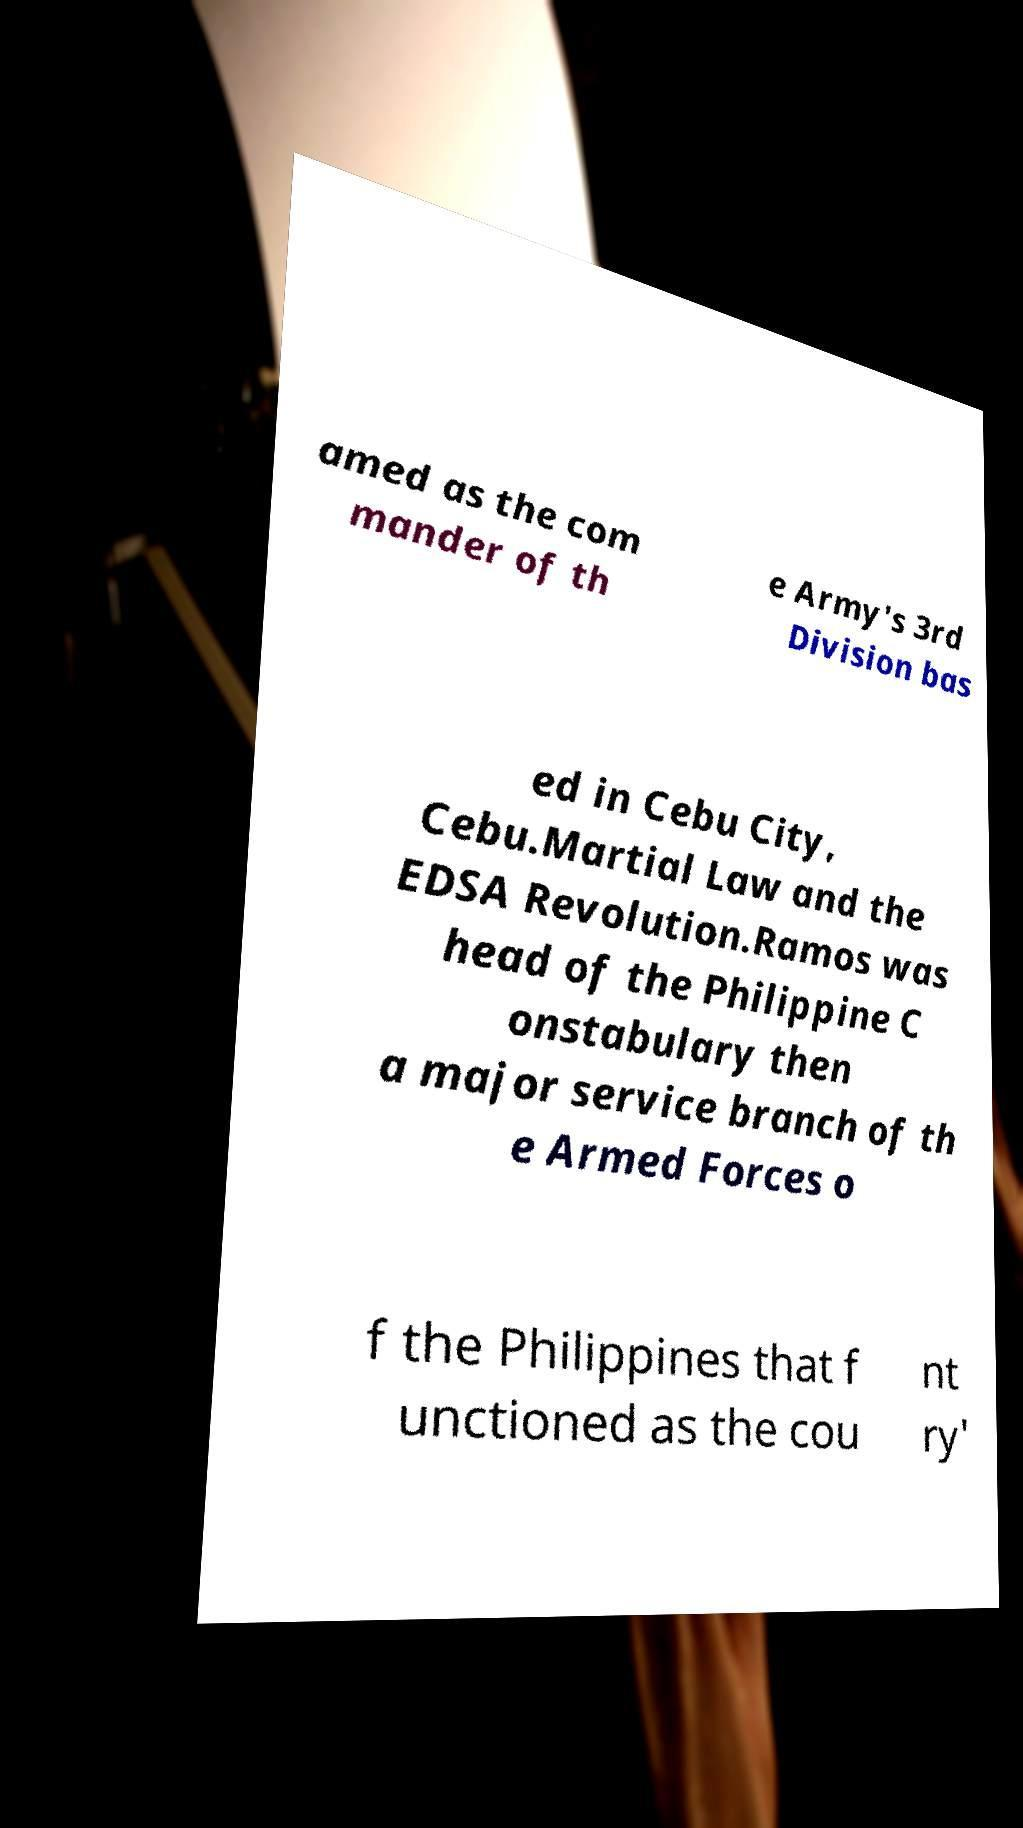Please read and relay the text visible in this image. What does it say? amed as the com mander of th e Army's 3rd Division bas ed in Cebu City, Cebu.Martial Law and the EDSA Revolution.Ramos was head of the Philippine C onstabulary then a major service branch of th e Armed Forces o f the Philippines that f unctioned as the cou nt ry' 